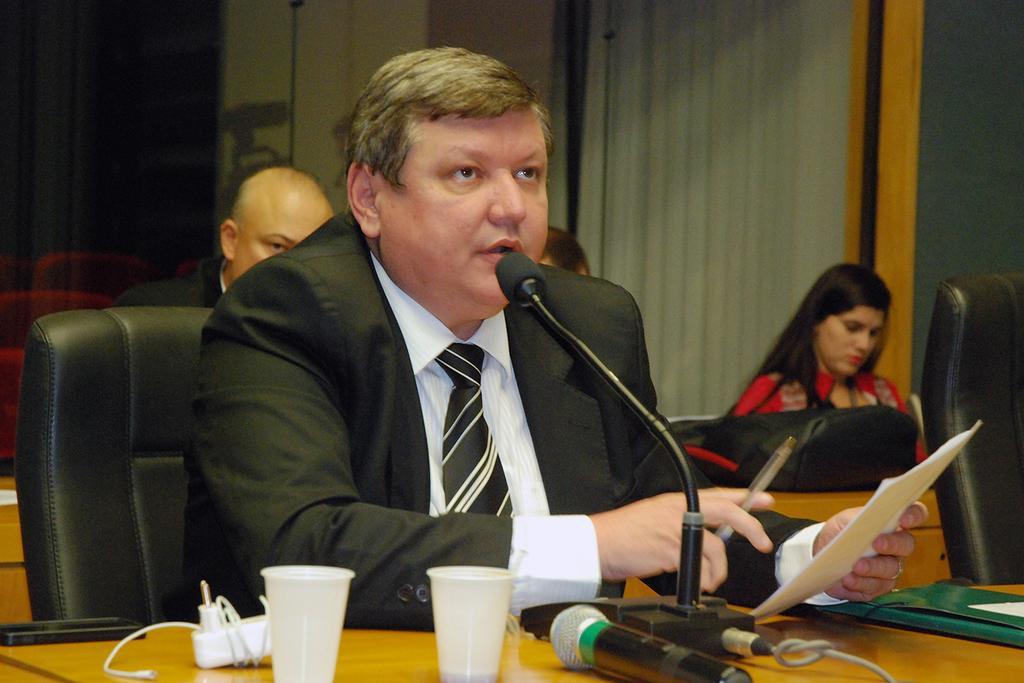How would you summarize this image in a sentence or two? This image is taken indoors. In the background there is a wall with a window and there is a curtain. Three people are sitting on the chairs. On the right side of the image there is an empty chair. In the middle of the image a man is sitting on the chair and he is holding a pen and papers in his hands. At the bottom of the image there is a table with a file, mics, glasses and a few things on it. 